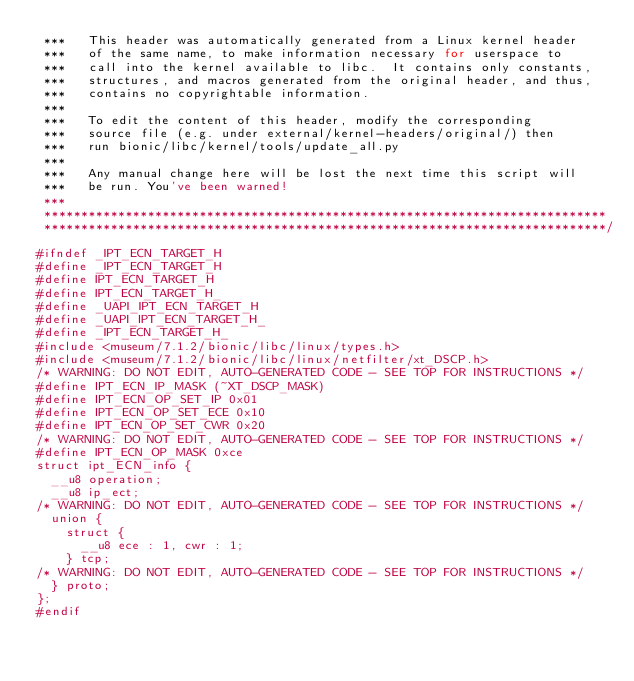<code> <loc_0><loc_0><loc_500><loc_500><_C_> ***   This header was automatically generated from a Linux kernel header
 ***   of the same name, to make information necessary for userspace to
 ***   call into the kernel available to libc.  It contains only constants,
 ***   structures, and macros generated from the original header, and thus,
 ***   contains no copyrightable information.
 ***
 ***   To edit the content of this header, modify the corresponding
 ***   source file (e.g. under external/kernel-headers/original/) then
 ***   run bionic/libc/kernel/tools/update_all.py
 ***
 ***   Any manual change here will be lost the next time this script will
 ***   be run. You've been warned!
 ***
 ****************************************************************************
 ****************************************************************************/
#ifndef _IPT_ECN_TARGET_H
#define _IPT_ECN_TARGET_H
#define IPT_ECN_TARGET_H
#define IPT_ECN_TARGET_H_
#define _UAPI_IPT_ECN_TARGET_H
#define _UAPI_IPT_ECN_TARGET_H_
#define _IPT_ECN_TARGET_H_
#include <museum/7.1.2/bionic/libc/linux/types.h>
#include <museum/7.1.2/bionic/libc/linux/netfilter/xt_DSCP.h>
/* WARNING: DO NOT EDIT, AUTO-GENERATED CODE - SEE TOP FOR INSTRUCTIONS */
#define IPT_ECN_IP_MASK (~XT_DSCP_MASK)
#define IPT_ECN_OP_SET_IP 0x01
#define IPT_ECN_OP_SET_ECE 0x10
#define IPT_ECN_OP_SET_CWR 0x20
/* WARNING: DO NOT EDIT, AUTO-GENERATED CODE - SEE TOP FOR INSTRUCTIONS */
#define IPT_ECN_OP_MASK 0xce
struct ipt_ECN_info {
  __u8 operation;
  __u8 ip_ect;
/* WARNING: DO NOT EDIT, AUTO-GENERATED CODE - SEE TOP FOR INSTRUCTIONS */
  union {
    struct {
      __u8 ece : 1, cwr : 1;
    } tcp;
/* WARNING: DO NOT EDIT, AUTO-GENERATED CODE - SEE TOP FOR INSTRUCTIONS */
  } proto;
};
#endif
</code> 